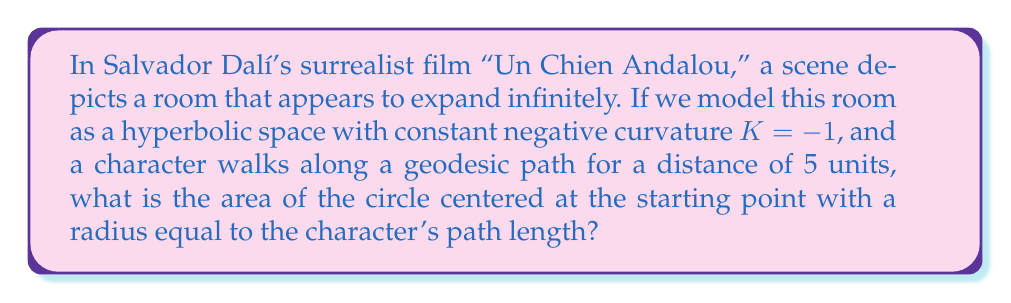Help me with this question. To solve this problem, we need to use concepts from non-Euclidean geometry, specifically hyperbolic geometry. In hyperbolic space, the area of a circle is different from what we're used to in Euclidean geometry.

1) In hyperbolic geometry with curvature $K = -1$, the area of a circle with radius $r$ is given by the formula:

   $$A = 4\pi \sinh^2(\frac{r}{2})$$

   where $\sinh$ is the hyperbolic sine function.

2) In our case, the radius $r$ is equal to 5 units.

3) Let's substitute this into our formula:

   $$A = 4\pi \sinh^2(\frac{5}{2})$$

4) To calculate this, we need to evaluate $\sinh(\frac{5}{2})$:

   $$\sinh(x) = \frac{e^x - e^{-x}}{2}$$

   $$\sinh(\frac{5}{2}) = \frac{e^{5/2} - e^{-5/2}}{2}$$

5) Using a calculator or computer:

   $$\sinh(\frac{5}{2}) \approx 6.0502$$

6) Now we can square this value:

   $$\sinh^2(\frac{5}{2}) \approx 36.6049$$

7) Finally, we multiply by $4\pi$:

   $$A = 4\pi \cdot 36.6049 \approx 459.9627$$

This result showcases how quickly area grows in hyperbolic space compared to Euclidean space, reflecting the surrealist notion of infinitely expanding rooms.
Answer: The area of the circle is approximately 459.9627 square units. 